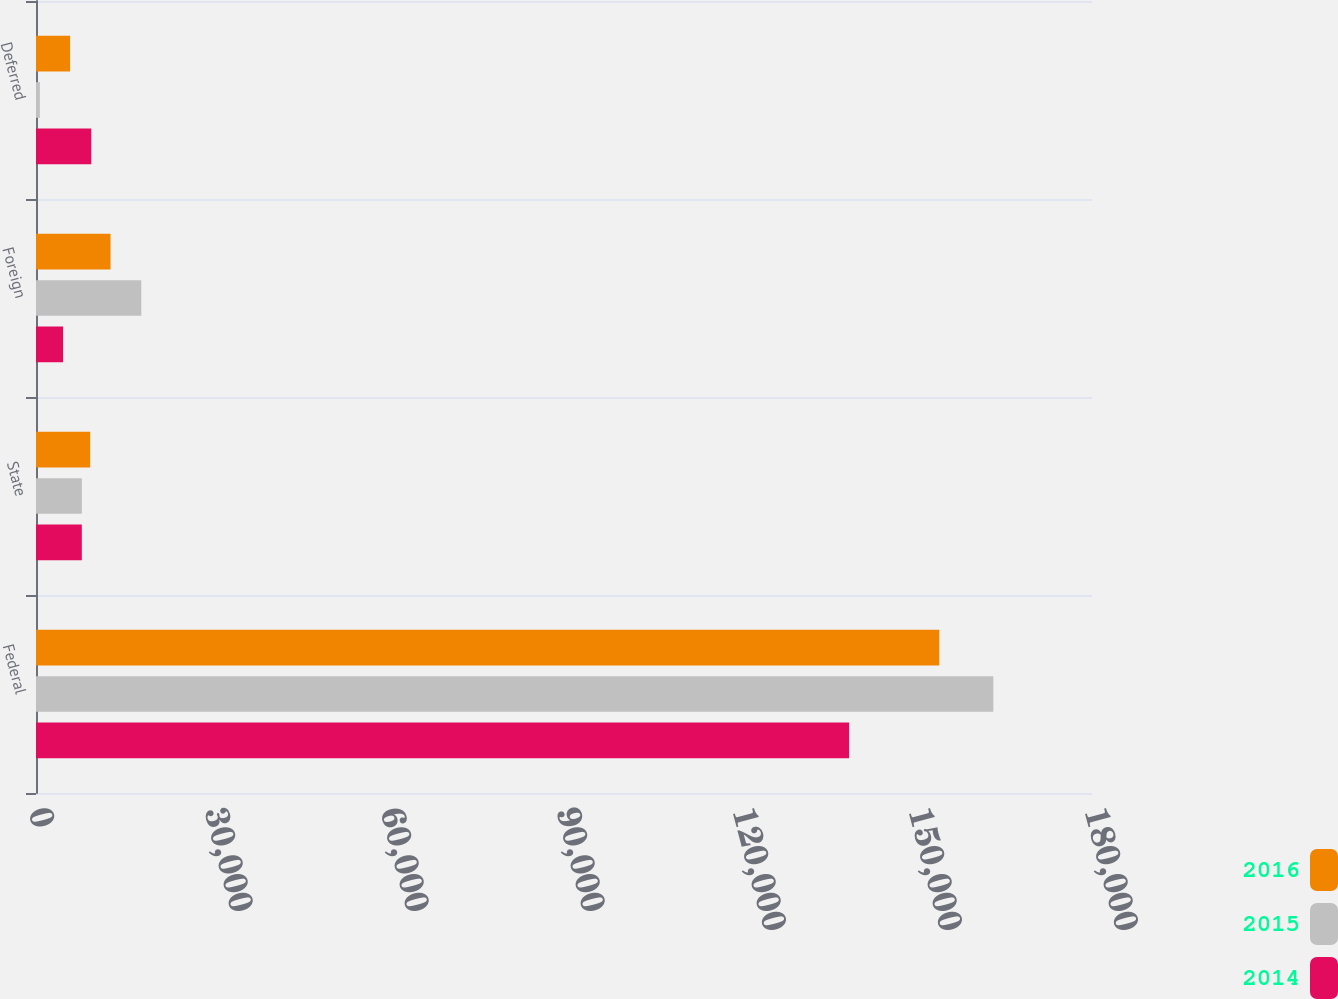Convert chart to OTSL. <chart><loc_0><loc_0><loc_500><loc_500><stacked_bar_chart><ecel><fcel>Federal<fcel>State<fcel>Foreign<fcel>Deferred<nl><fcel>2016<fcel>153957<fcel>9234<fcel>12703<fcel>5808<nl><fcel>2015<fcel>163182<fcel>7823<fcel>17947<fcel>660<nl><fcel>2014<fcel>138596<fcel>7807<fcel>4613<fcel>9416<nl></chart> 